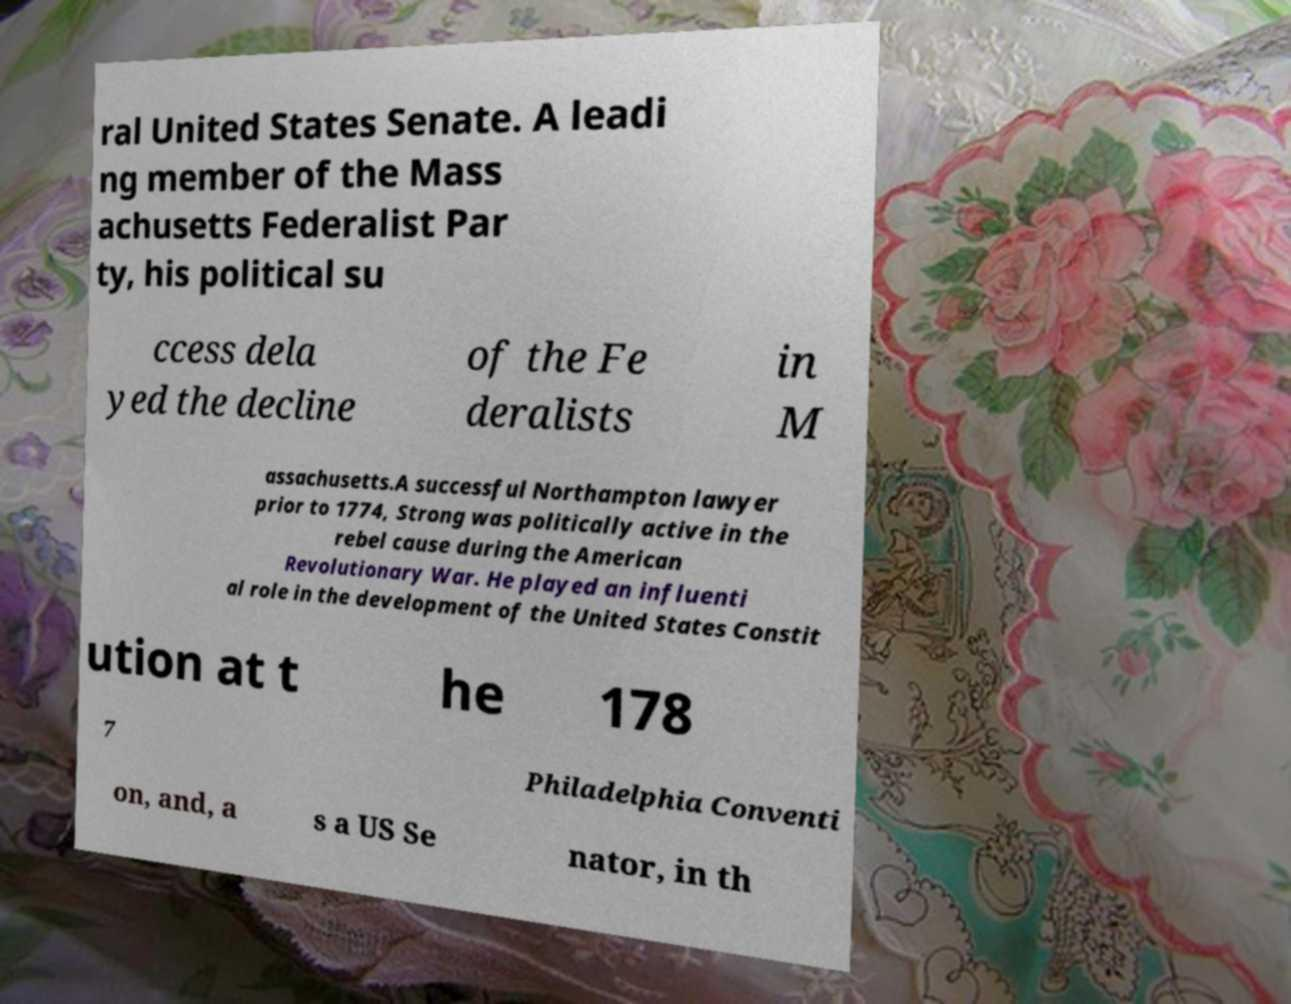Please read and relay the text visible in this image. What does it say? ral United States Senate. A leadi ng member of the Mass achusetts Federalist Par ty, his political su ccess dela yed the decline of the Fe deralists in M assachusetts.A successful Northampton lawyer prior to 1774, Strong was politically active in the rebel cause during the American Revolutionary War. He played an influenti al role in the development of the United States Constit ution at t he 178 7 Philadelphia Conventi on, and, a s a US Se nator, in th 